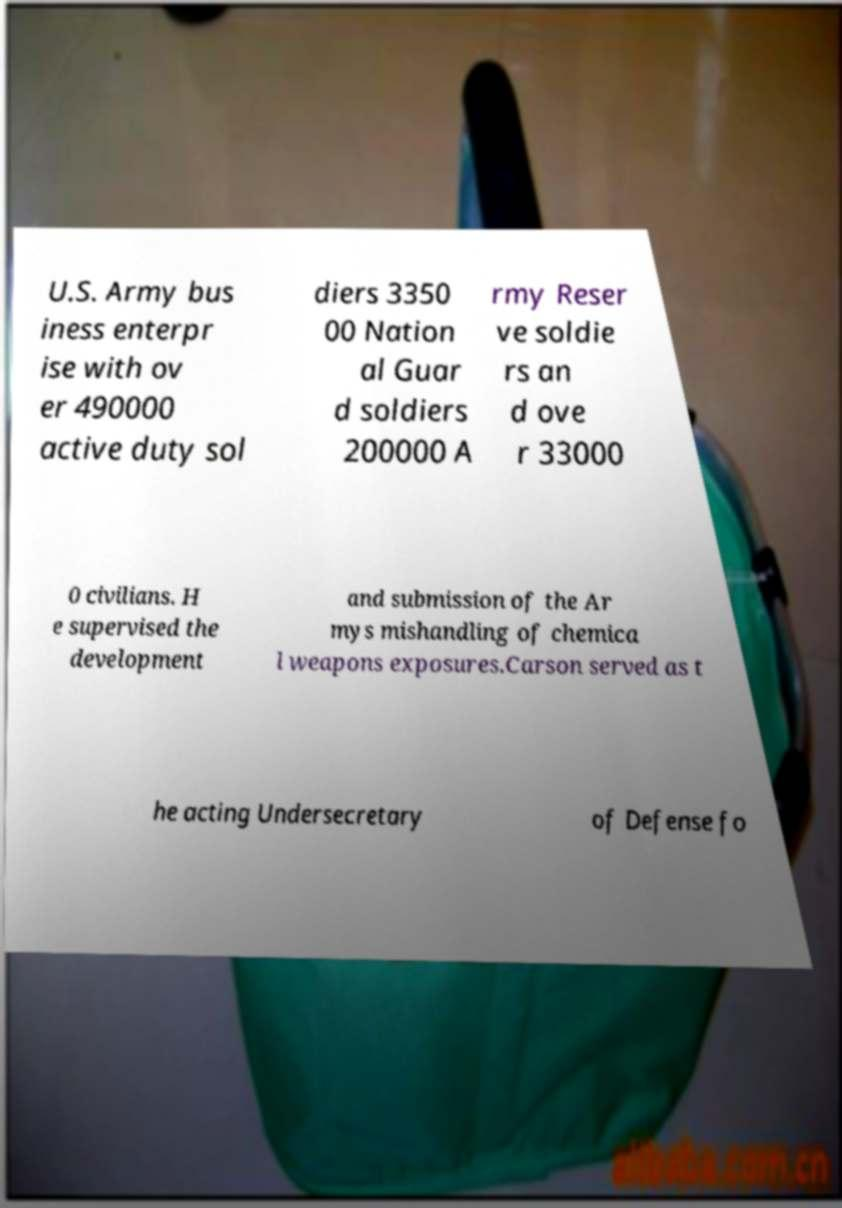For documentation purposes, I need the text within this image transcribed. Could you provide that? U.S. Army bus iness enterpr ise with ov er 490000 active duty sol diers 3350 00 Nation al Guar d soldiers 200000 A rmy Reser ve soldie rs an d ove r 33000 0 civilians. H e supervised the development and submission of the Ar mys mishandling of chemica l weapons exposures.Carson served as t he acting Undersecretary of Defense fo 